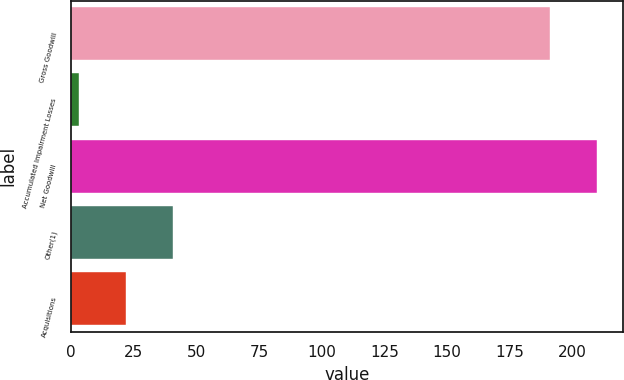Convert chart. <chart><loc_0><loc_0><loc_500><loc_500><bar_chart><fcel>Gross Goodwill<fcel>Accumulated Impairment Losses<fcel>Net Goodwill<fcel>Other(1)<fcel>Acquisitions<nl><fcel>191<fcel>2.98<fcel>209.8<fcel>40.58<fcel>21.78<nl></chart> 